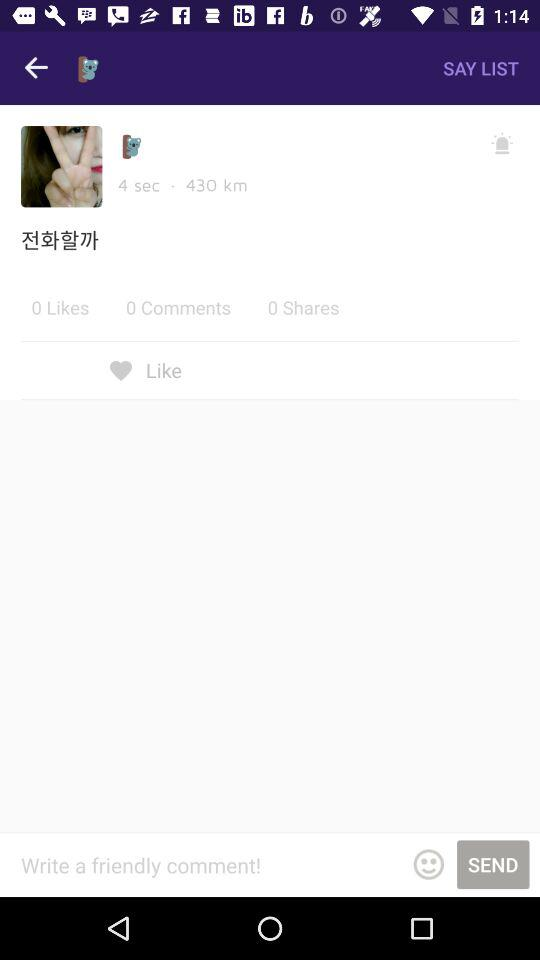How many shares are there? There are 0 shares. 